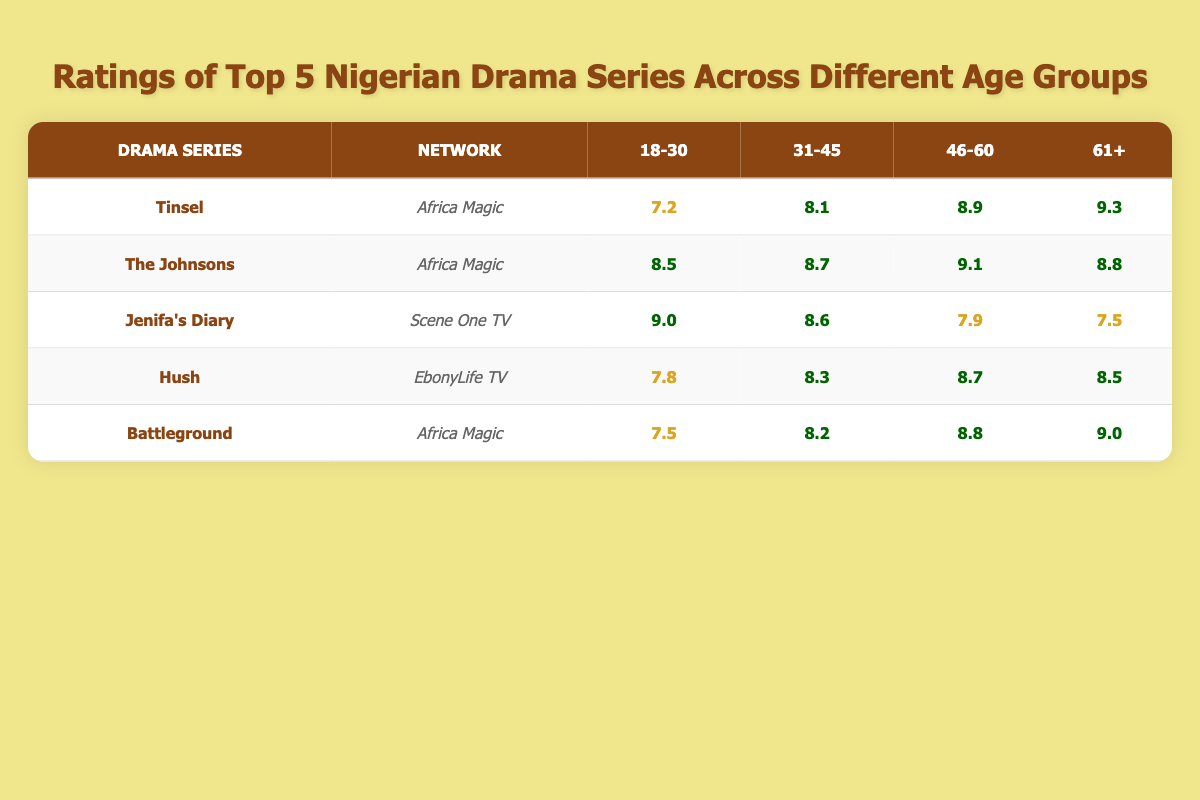What is the highest rating for the series 'Tinsel' among all age groups? The table shows the ratings for 'Tinsel' across age groups: 7.2 (18-30), 8.1 (31-45), 8.9 (46-60), and 9.3 (61+). Therefore, the highest rating for 'Tinsel' is 9.3 in the 61+ age group.
Answer: 9.3 Which drama series has the lowest rating in the 18-30 age group? Looking at the 18-30 column, the ratings are: Tinsel (7.2), The Johnsons (8.5), Jenifa's Diary (9.0), Hush (7.8), and Battleground (7.5). The lowest rating among these is 7.2 for 'Tinsel'.
Answer: 7.2 Is the rating for 'Hush' higher in the 61+ age group than in the 31-45 age group? The rating for 'Hush' in the 61+ age group is 8.5 and in the 31-45 age group it is 8.3. Since 8.5 is greater than 8.3, the rating for 'Hush' is indeed higher in the 61+ age group.
Answer: Yes What is the average rating for 'The Johnsons' across all age groups? The ratings for 'The Johnsons' are: 8.5 (18-30), 8.7 (31-45), 9.1 (46-60), and 8.8 (61+). The sum of these ratings is 8.5 + 8.7 + 9.1 + 8.8 = 35.1. Dividing by the number of age groups (4) gives the average: 35.1 / 4 = 8.775.
Answer: 8.775 Which drama series received the highest rating in the 46-60 age group? In the 46-60 age group, the ratings are: Tinsel (8.9), The Johnsons (9.1), Jenifa's Diary (7.9), Hush (8.7), and Battleground (8.8). The highest rating is 9.1 for 'The Johnsons'.
Answer: The Johnsons 